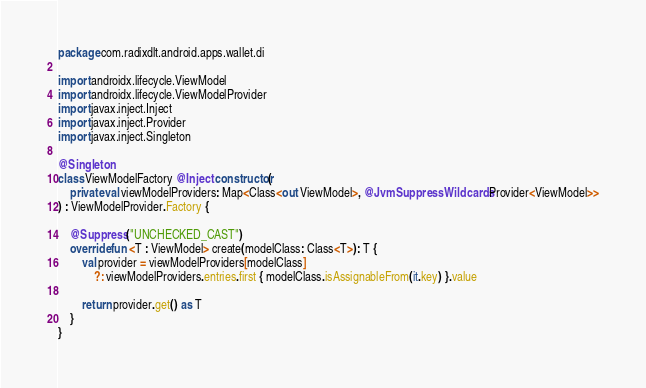<code> <loc_0><loc_0><loc_500><loc_500><_Kotlin_>package com.radixdlt.android.apps.wallet.di

import androidx.lifecycle.ViewModel
import androidx.lifecycle.ViewModelProvider
import javax.inject.Inject
import javax.inject.Provider
import javax.inject.Singleton

@Singleton
class ViewModelFactory @Inject constructor(
    private val viewModelProviders: Map<Class<out ViewModel>, @JvmSuppressWildcards Provider<ViewModel>>
) : ViewModelProvider.Factory {

    @Suppress("UNCHECKED_CAST")
    override fun <T : ViewModel> create(modelClass: Class<T>): T {
        val provider = viewModelProviders[modelClass]
            ?: viewModelProviders.entries.first { modelClass.isAssignableFrom(it.key) }.value

        return provider.get() as T
    }
}
</code> 